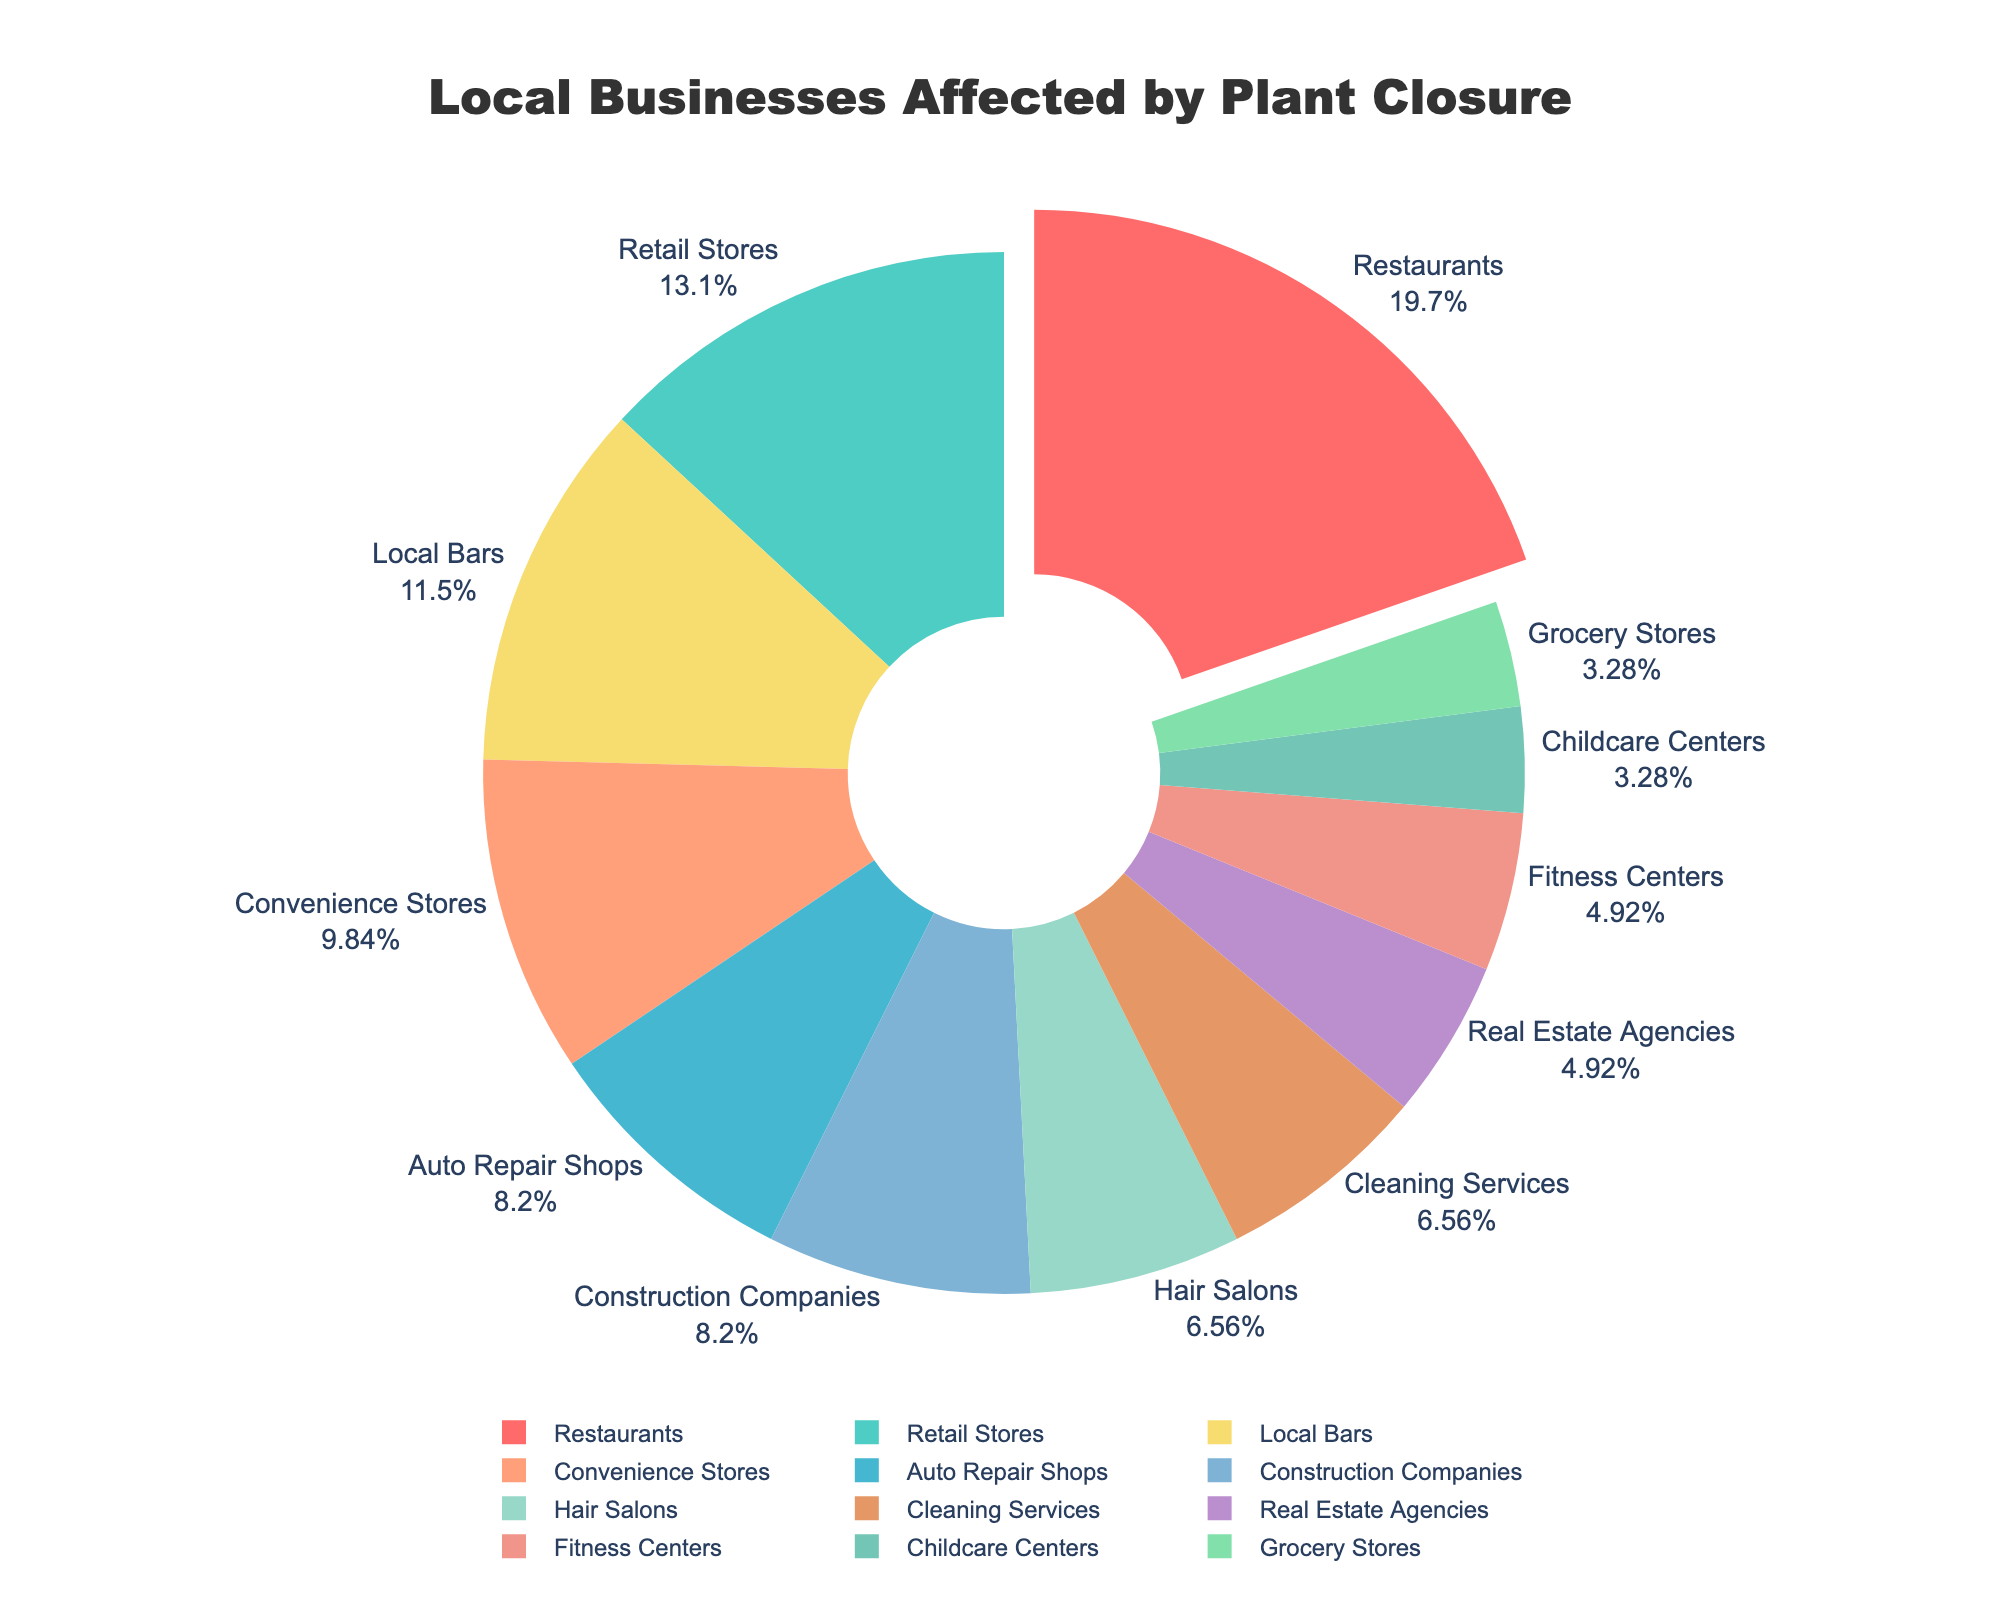Which type of business is affected the most? The pie chart shows the size and percentage of each segment. The largest segment represents Restaurants, indicating that they're the most affected.
Answer: Restaurants What's the total number of businesses affected by the plant closure? Add up the numbers from each business type: 12(Restaurants) + 8(Retail Stores) + 5(Auto Repair Shops) + 6(Convenience Stores) + 4(Hair Salons) + 7(Local Bars) + 3(Real Estate Agencies) + 5(Construction Companies) + 4(Cleaning Services) + 2(Childcare Centers) + 3(Fitness Centers) + 2(Grocery Stores) = 61
Answer: 61 Which two types of businesses have the same number affected? By looking at the pie chart, you can see that Hair Salons and Cleaning Services both have 4 businesses affected, as well as Childcare Centers and Grocery Stores both have 2 businesses affected.
Answer: Hair Salons and Cleaning Services, Childcare Centers and Grocery Stores Are there more Auto Repair Shops or Convenience Stores affected? Compare the sizes of the segments for Auto Repair Shops and Convenience Stores. Auto Repair Shops are 5, and Convenience Stores are 6.
Answer: Convenience Stores What fraction of the affected businesses are Local Bars? Local Bars have 7 affected businesses out of a total of 61. The fraction is 7/61.
Answer: 7/61 How many more Restaurants are affected compared to Hair Salons? Subtract the number of affected Hair Salons from the number of affected Restaurants: 12(Restaurants) - 4(Hair Salons) = 8
Answer: 8 What percentage of the total affected businesses are Retail Stores? Retail Stores have 8 affected businesses. Calculate the percentage: (8/61) * 100 ≈ 13.11%
Answer: Around 13.11% Which business type represents about one-eighth of the affected businesses? One-eighth of the total 61 businesses is approximately 7.625 (61/8). Local Bars have 7 affected, which is close to one-eighth.
Answer: Local Bars If you combine the number of affected Childcare Centers and Fitness Centers, how many businesses is that in total? Add the affected Childcare Centers and Fitness Centers: 2(Childcare Centers) + 3(Fitness Centers) = 5
Answer: 5 